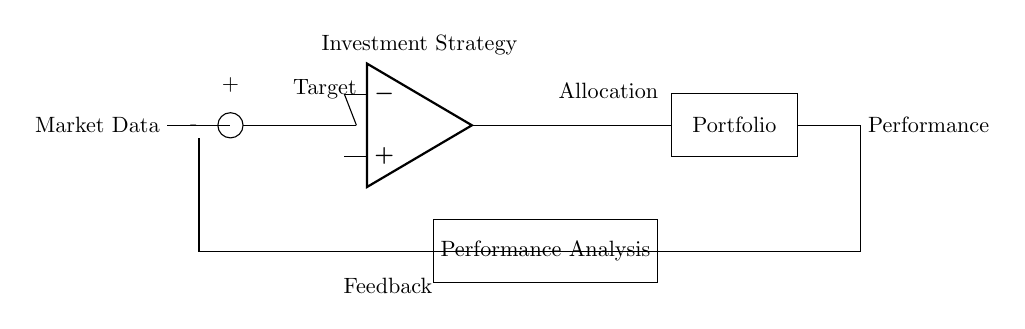What is the input to the system? The input to the system is labeled as "Market Data," which indicates that it serves as the primary variable the system reacts to in order to adjust performance.
Answer: Market Data What is the function of the summing junction? The summing junction processes the "Market Data" and the feedback from the "Performance Analysis" to compute the difference, influencing the subsequent investment strategy.
Answer: Computes difference What does the op-amp represent in this circuit? The op-amp symbolizes the investment strategy, functioning as the decision-maker that adjusts the investment based on the processed input and feedback received.
Answer: Investment Strategy What feedback is used in the system? The feedback is derived from "Performance Analysis," which evaluates the performance of the portfolio and feeds the results back to the summing junction for adjustment purposes.
Answer: Performance Analysis What is the output of the op-amp? The output of the op-amp leads to the "Portfolio," indicating that it sends the adjusted investment strategy based on the processed data and feedback provided.
Answer: Portfolio How does the feedback loop function? The feedback loop connects the output performance back to the summing junction to allow continuous adjustments based on the difference between target and actual performance, establishing a self-regulating system.
Answer: Continuous adjustments What is the target in the circuit? The target is the intended performance level that the system aims to achieve, as indicated by the label above the summing junction.
Answer: Target 